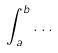Convert formula to latex. <formula><loc_0><loc_0><loc_500><loc_500>\int _ { a } ^ { b } \dots</formula> 